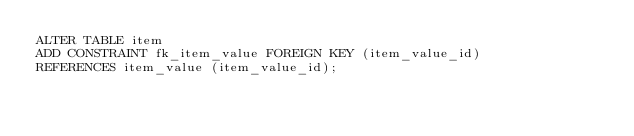Convert code to text. <code><loc_0><loc_0><loc_500><loc_500><_SQL_>ALTER TABLE item
ADD CONSTRAINT fk_item_value FOREIGN KEY (item_value_id)
REFERENCES item_value (item_value_id);
</code> 